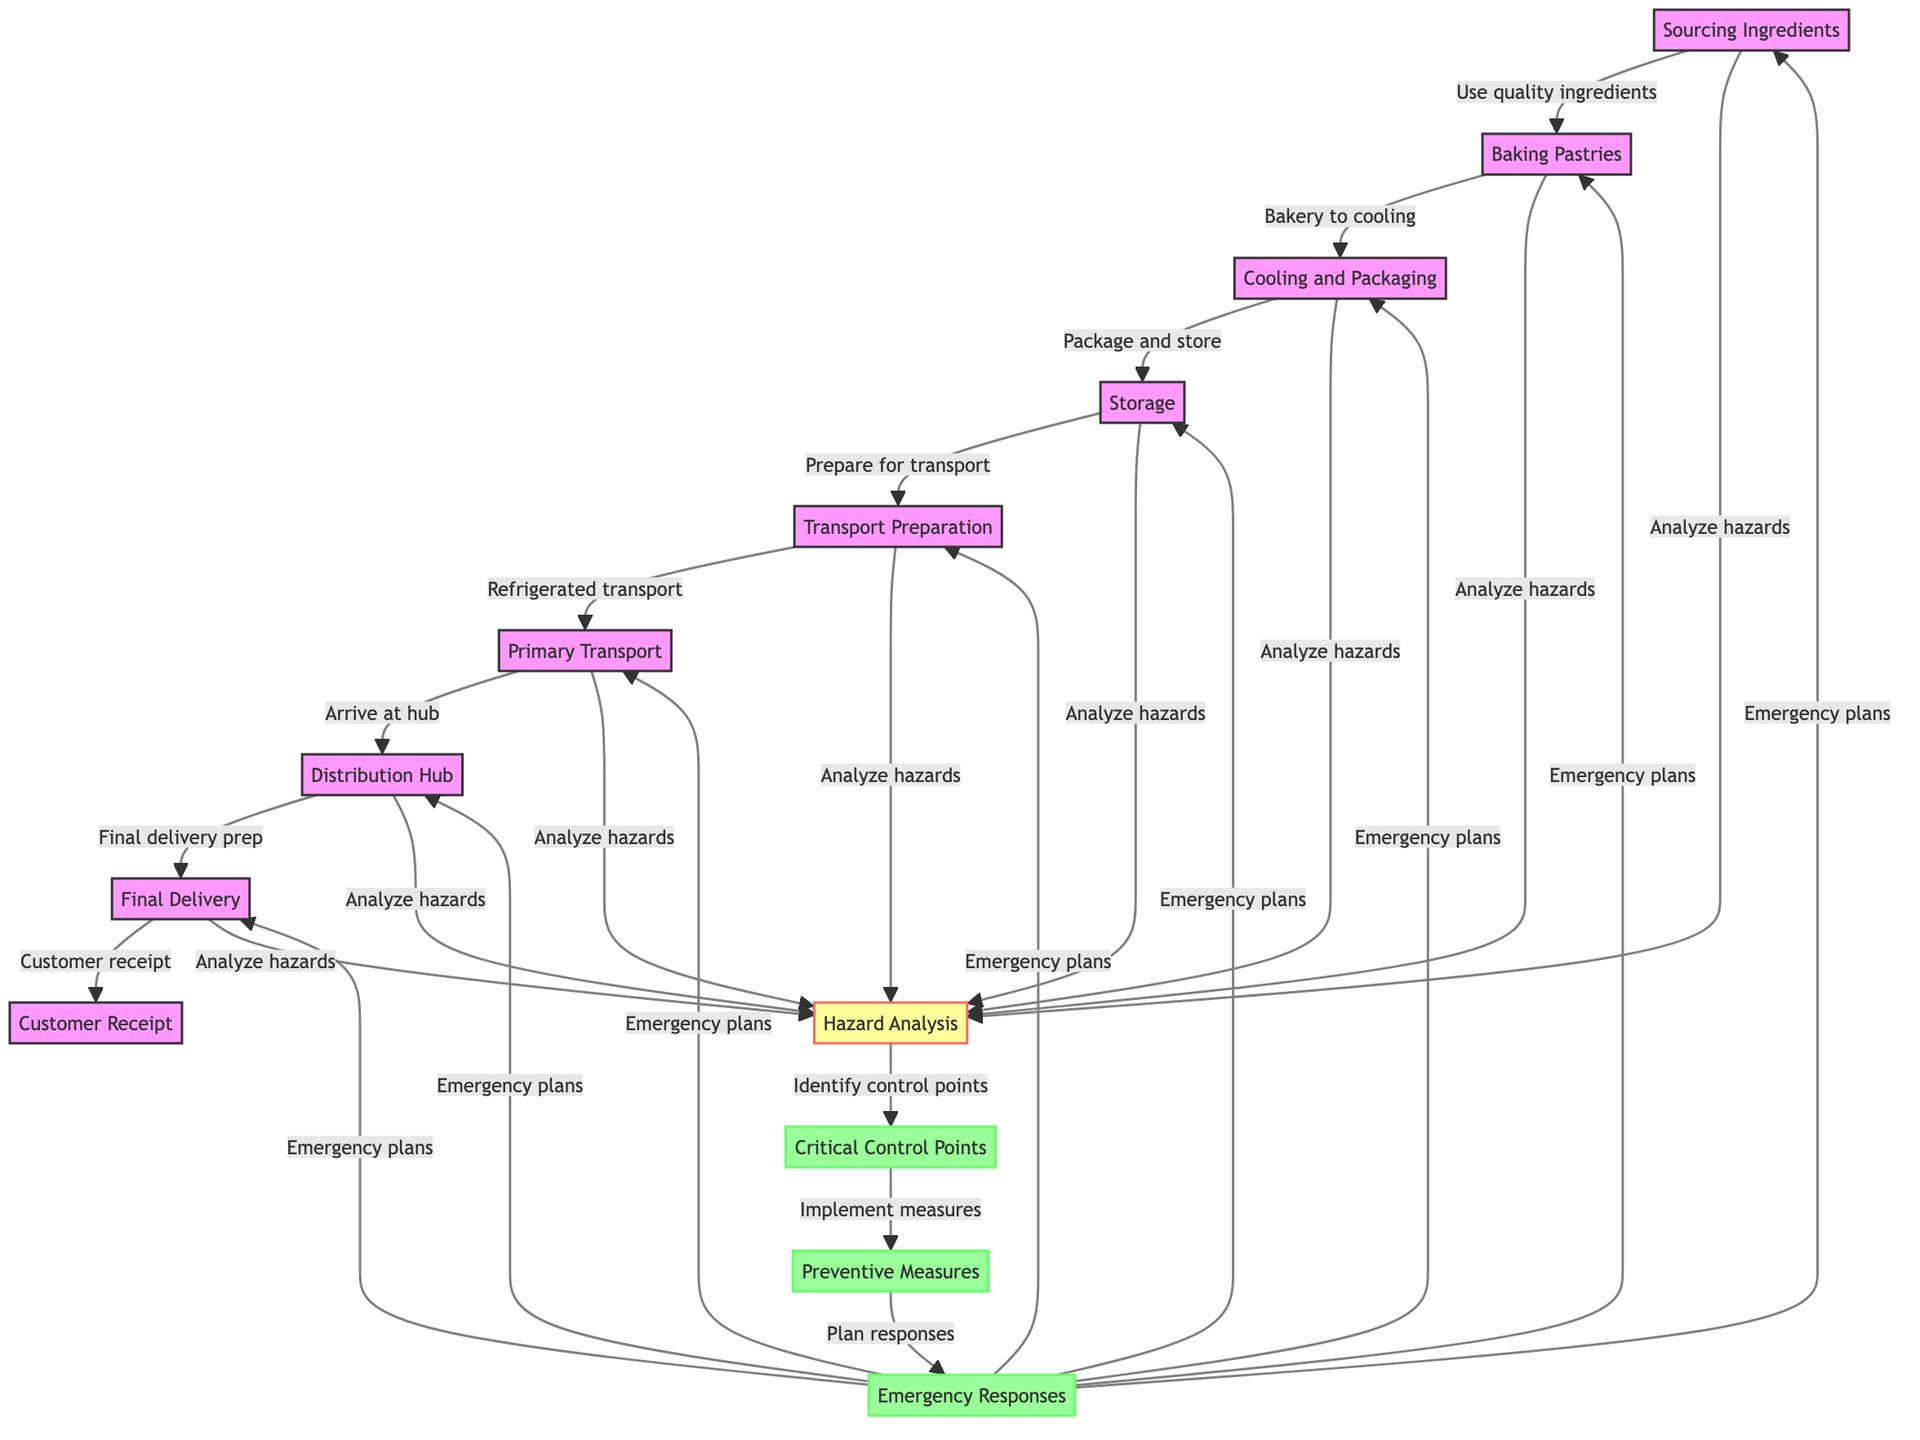What are the four main stages of pastry preparation in this diagram? The diagram shows four stages: Sourcing Ingredients, Baking Pastries, Cooling and Packaging, and Storage.
Answer: Sourcing Ingredients, Baking Pastries, Cooling and Packaging, Storage How many nodes are present in the diagram? The diagram includes a total of 13 nodes, counting from Sourcing Ingredients to Customer Receipt and including hazards, control points, preventive measures, and emergency responses.
Answer: 13 What is the role of Critical Control Points in this food chain? Critical Control Points, represented by node 11, are identified after analyzing hazards and are essential for implementing preventive measures to safeguard the pastries during their journey.
Answer: Identify control points Which process is directly after Transport Preparation? The process directly after Transport Preparation is Primary Transport. This is a straightforward flow where one stage leads to the next.
Answer: Primary Transport Can you name one preventive measure identified in the HACCP analysis? One preventive measure mentioned is the implementation of measures that take place after identifying control points. It specifically aims to prevent hazards in the food logistics process.
Answer: Implement measures What happens if an emergency arises during the shipping process? If an emergency arises, the plan for emergency responses would be triggered, which encompasses the entire food chain activities. This shows the importance of emergency preparedness in every stage from sourcing to delivery.
Answer: Emergency plans How does the diagram connect Customer Receipt to Sourcing Ingredients? The diagram illustrates that Customer Receipt leads back to Sourcing Ingredients as part of the emergency response plan, creating a cyclical flow in case of any issues with the pastries that necessitate going back to the beginning of the process.
Answer: Emergency plans What are the two hazards analyzed in this food chain? The diagram groups hazards under the general node Hazard Analysis, which leads to identifying control points. Importantly, the specific hazards are not explicitly detailed on the diagram, but their analysis is a key part of the process.
Answer: Analyze hazards Which node follows directly after Cooling and Packaging? The node that follows directly after Cooling and Packaging is Storage, which indicates the next crucial step in the process of handling delicate pastries.
Answer: Storage 